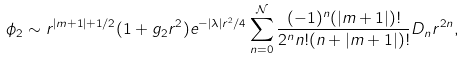Convert formula to latex. <formula><loc_0><loc_0><loc_500><loc_500>\phi _ { 2 } \sim r ^ { | m + 1 | + 1 / 2 } ( 1 + g _ { 2 } r ^ { 2 } ) e ^ { - | \lambda | r ^ { 2 } / 4 } \sum _ { n = 0 } ^ { \mathcal { N } } \frac { ( - 1 ) ^ { n } ( | m + 1 | ) ! } { 2 ^ { n } n ! ( n + | m + 1 | ) ! } D _ { n } r ^ { 2 n } ,</formula> 